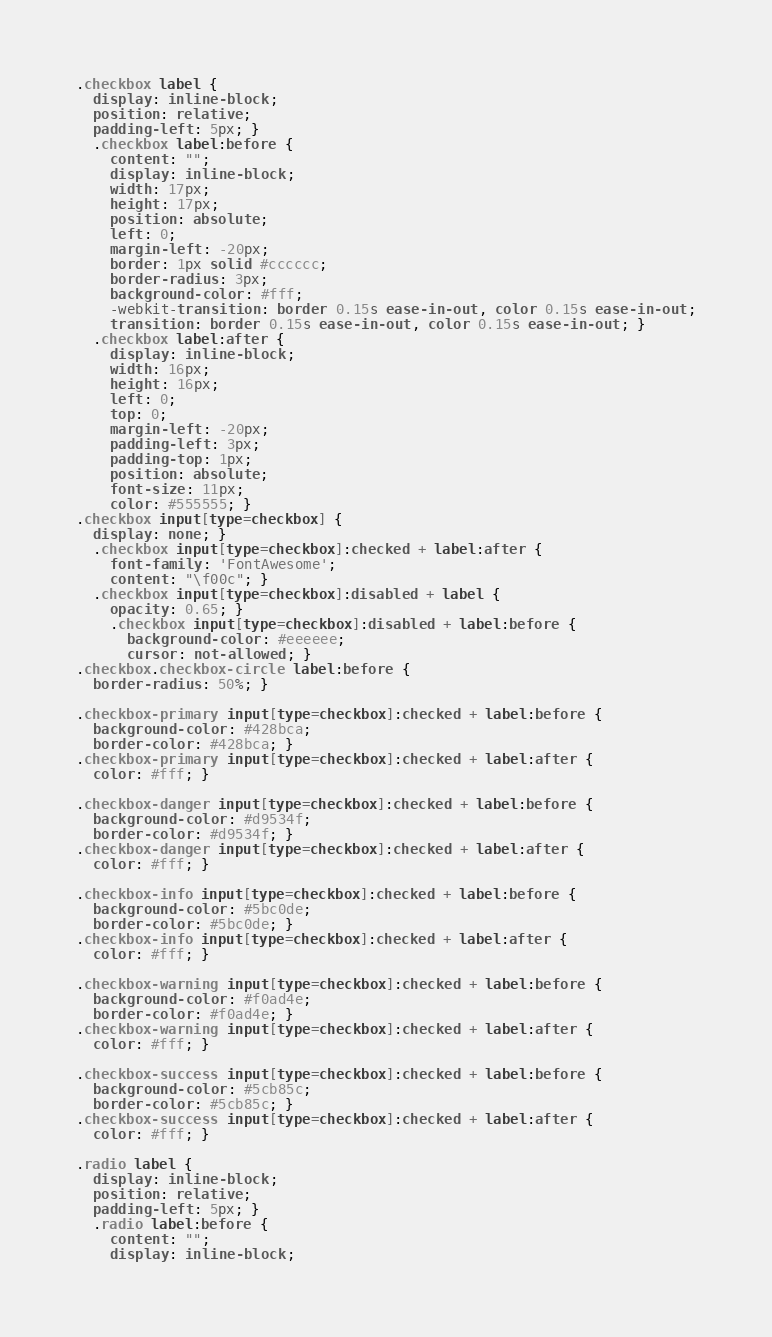Convert code to text. <code><loc_0><loc_0><loc_500><loc_500><_CSS_>.checkbox label {
  display: inline-block;
  position: relative;
  padding-left: 5px; }
  .checkbox label:before {
    content: "";
    display: inline-block;
    width: 17px;
    height: 17px;
    position: absolute;
    left: 0;
    margin-left: -20px;
    border: 1px solid #cccccc;
    border-radius: 3px;
    background-color: #fff;
    -webkit-transition: border 0.15s ease-in-out, color 0.15s ease-in-out;
    transition: border 0.15s ease-in-out, color 0.15s ease-in-out; }
  .checkbox label:after {
    display: inline-block;
    width: 16px;
    height: 16px;
    left: 0;
    top: 0;
    margin-left: -20px;
    padding-left: 3px;
    padding-top: 1px;
    position: absolute;
    font-size: 11px;
    color: #555555; }
.checkbox input[type=checkbox] {
  display: none; }
  .checkbox input[type=checkbox]:checked + label:after {
    font-family: 'FontAwesome';
    content: "\f00c"; }
  .checkbox input[type=checkbox]:disabled + label {
    opacity: 0.65; }
    .checkbox input[type=checkbox]:disabled + label:before {
      background-color: #eeeeee;
      cursor: not-allowed; }
.checkbox.checkbox-circle label:before {
  border-radius: 50%; }

.checkbox-primary input[type=checkbox]:checked + label:before {
  background-color: #428bca;
  border-color: #428bca; }
.checkbox-primary input[type=checkbox]:checked + label:after {
  color: #fff; }

.checkbox-danger input[type=checkbox]:checked + label:before {
  background-color: #d9534f;
  border-color: #d9534f; }
.checkbox-danger input[type=checkbox]:checked + label:after {
  color: #fff; }

.checkbox-info input[type=checkbox]:checked + label:before {
  background-color: #5bc0de;
  border-color: #5bc0de; }
.checkbox-info input[type=checkbox]:checked + label:after {
  color: #fff; }

.checkbox-warning input[type=checkbox]:checked + label:before {
  background-color: #f0ad4e;
  border-color: #f0ad4e; }
.checkbox-warning input[type=checkbox]:checked + label:after {
  color: #fff; }

.checkbox-success input[type=checkbox]:checked + label:before {
  background-color: #5cb85c;
  border-color: #5cb85c; }
.checkbox-success input[type=checkbox]:checked + label:after {
  color: #fff; }

.radio label {
  display: inline-block;
  position: relative;
  padding-left: 5px; }
  .radio label:before {
    content: "";
    display: inline-block;</code> 